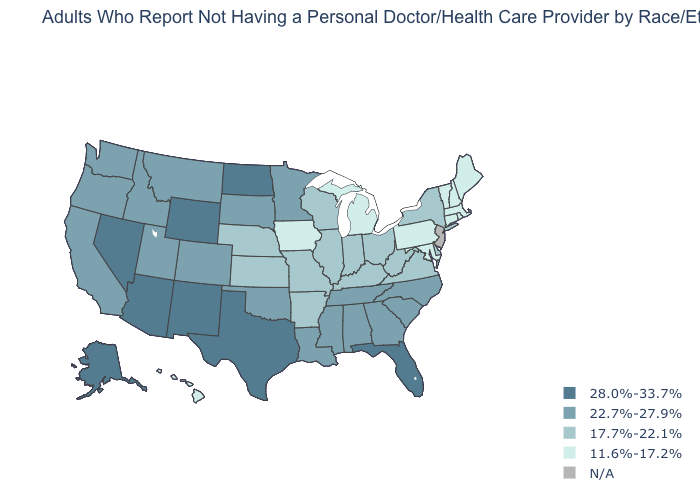Does Indiana have the highest value in the MidWest?
Keep it brief. No. Is the legend a continuous bar?
Concise answer only. No. What is the lowest value in the USA?
Keep it brief. 11.6%-17.2%. What is the value of South Dakota?
Be succinct. 22.7%-27.9%. Which states hav the highest value in the MidWest?
Answer briefly. North Dakota. Which states have the lowest value in the USA?
Be succinct. Connecticut, Hawaii, Iowa, Maine, Maryland, Massachusetts, Michigan, New Hampshire, Pennsylvania, Rhode Island, Vermont. What is the lowest value in the MidWest?
Be succinct. 11.6%-17.2%. What is the value of New Hampshire?
Answer briefly. 11.6%-17.2%. Which states have the lowest value in the USA?
Write a very short answer. Connecticut, Hawaii, Iowa, Maine, Maryland, Massachusetts, Michigan, New Hampshire, Pennsylvania, Rhode Island, Vermont. Among the states that border Maryland , which have the highest value?
Concise answer only. Delaware, Virginia, West Virginia. What is the value of Georgia?
Write a very short answer. 22.7%-27.9%. Name the states that have a value in the range 22.7%-27.9%?
Answer briefly. Alabama, California, Colorado, Georgia, Idaho, Louisiana, Minnesota, Mississippi, Montana, North Carolina, Oklahoma, Oregon, South Carolina, South Dakota, Tennessee, Utah, Washington. 